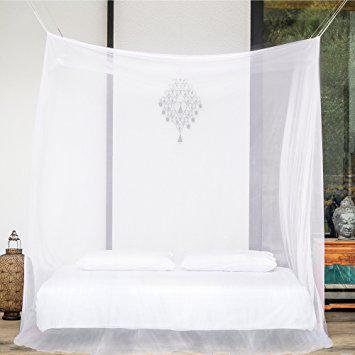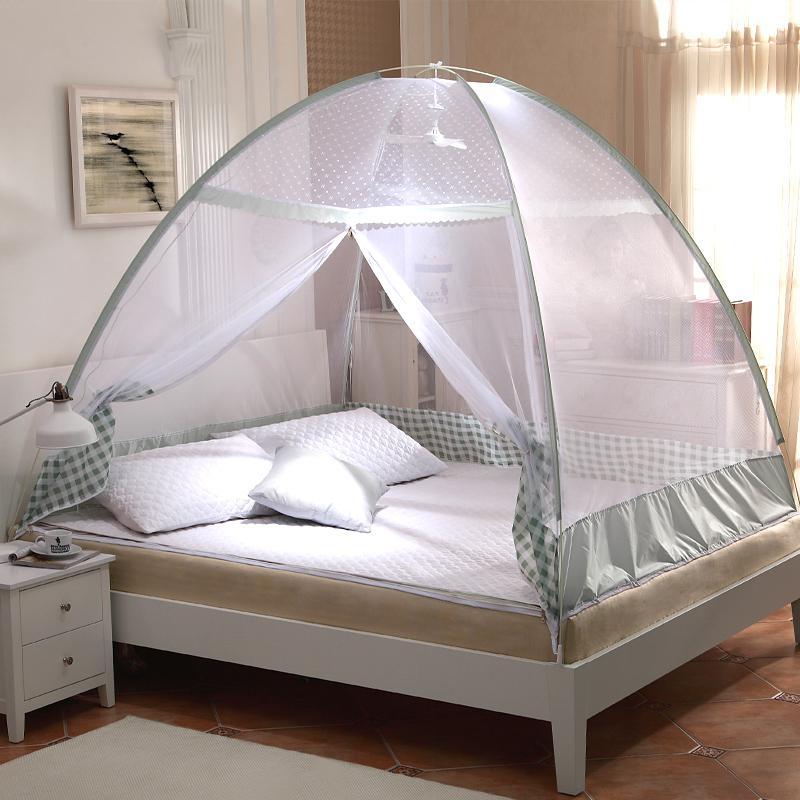The first image is the image on the left, the second image is the image on the right. Evaluate the accuracy of this statement regarding the images: "None of the nets above the bed are pink or yellow.". Is it true? Answer yes or no. Yes. 